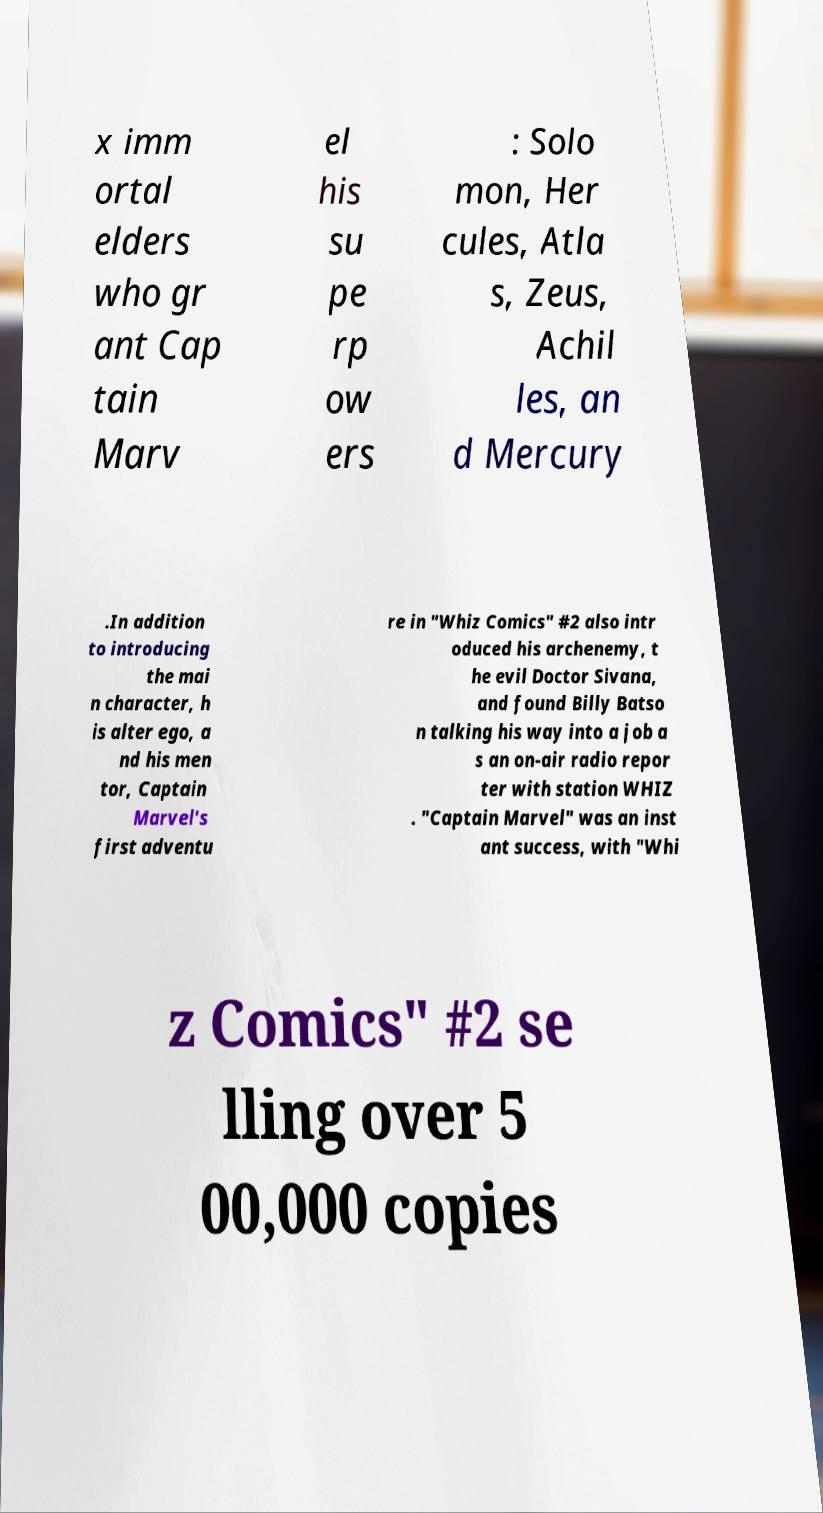Could you assist in decoding the text presented in this image and type it out clearly? x imm ortal elders who gr ant Cap tain Marv el his su pe rp ow ers : Solo mon, Her cules, Atla s, Zeus, Achil les, an d Mercury .In addition to introducing the mai n character, h is alter ego, a nd his men tor, Captain Marvel's first adventu re in "Whiz Comics" #2 also intr oduced his archenemy, t he evil Doctor Sivana, and found Billy Batso n talking his way into a job a s an on-air radio repor ter with station WHIZ . "Captain Marvel" was an inst ant success, with "Whi z Comics" #2 se lling over 5 00,000 copies 